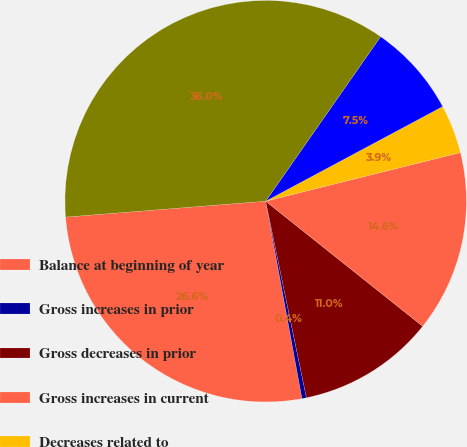Convert chart to OTSL. <chart><loc_0><loc_0><loc_500><loc_500><pie_chart><fcel>Balance at beginning of year<fcel>Gross increases in prior<fcel>Gross decreases in prior<fcel>Gross increases in current<fcel>Decreases related to<fcel>Decreases from the expiration<fcel>Balance at end of year<nl><fcel>26.63%<fcel>0.36%<fcel>11.04%<fcel>14.6%<fcel>3.92%<fcel>7.48%<fcel>35.96%<nl></chart> 